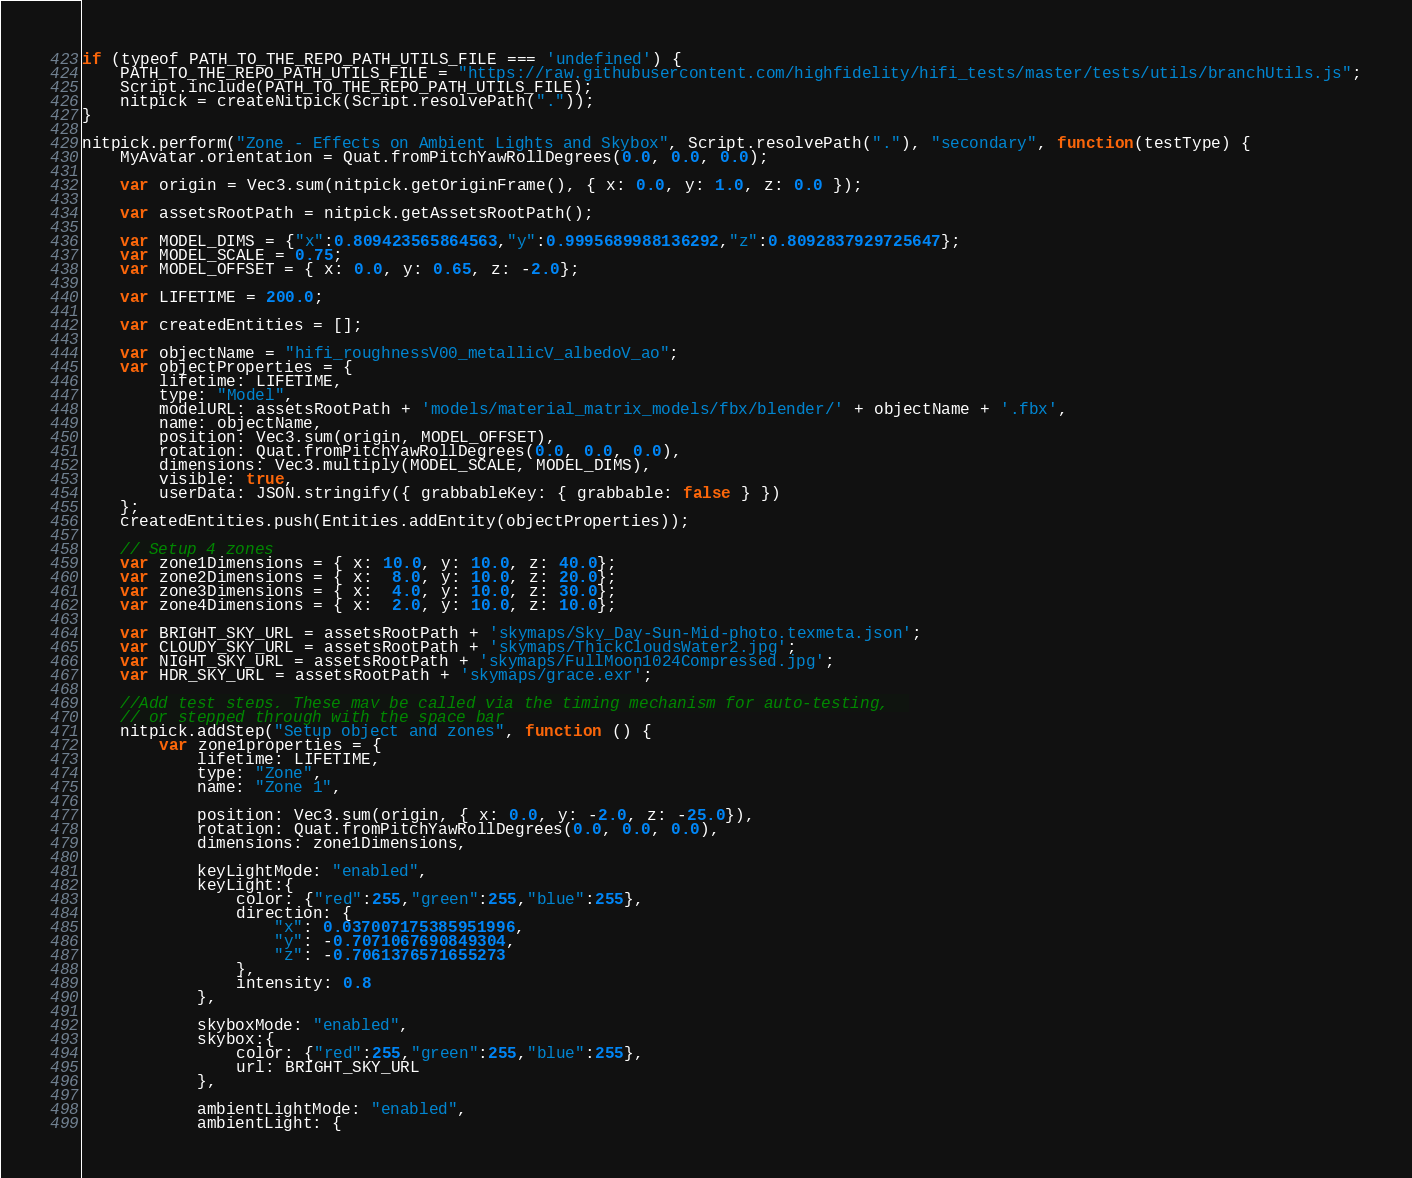Convert code to text. <code><loc_0><loc_0><loc_500><loc_500><_JavaScript_>if (typeof PATH_TO_THE_REPO_PATH_UTILS_FILE === 'undefined') {
    PATH_TO_THE_REPO_PATH_UTILS_FILE = "https://raw.githubusercontent.com/highfidelity/hifi_tests/master/tests/utils/branchUtils.js";
    Script.include(PATH_TO_THE_REPO_PATH_UTILS_FILE);
    nitpick = createNitpick(Script.resolvePath("."));
}

nitpick.perform("Zone - Effects on Ambient Lights and Skybox", Script.resolvePath("."), "secondary", function(testType) {
    MyAvatar.orientation = Quat.fromPitchYawRollDegrees(0.0, 0.0, 0.0);

    var origin = Vec3.sum(nitpick.getOriginFrame(), { x: 0.0, y: 1.0, z: 0.0 });

    var assetsRootPath = nitpick.getAssetsRootPath();

    var MODEL_DIMS = {"x":0.809423565864563,"y":0.9995689988136292,"z":0.8092837929725647};
    var MODEL_SCALE = 0.75;
    var MODEL_OFFSET = { x: 0.0, y: 0.65, z: -2.0};

    var LIFETIME = 200.0;

    var createdEntities = [];

    var objectName = "hifi_roughnessV00_metallicV_albedoV_ao";
    var objectProperties = {
        lifetime: LIFETIME,
        type: "Model",
        modelURL: assetsRootPath + 'models/material_matrix_models/fbx/blender/' + objectName + '.fbx',
        name: objectName,
        position: Vec3.sum(origin, MODEL_OFFSET),
        rotation: Quat.fromPitchYawRollDegrees(0.0, 0.0, 0.0),
        dimensions: Vec3.multiply(MODEL_SCALE, MODEL_DIMS),
        visible: true,
        userData: JSON.stringify({ grabbableKey: { grabbable: false } })
    };
    createdEntities.push(Entities.addEntity(objectProperties));

    // Setup 4 zones
    var zone1Dimensions = { x: 10.0, y: 10.0, z: 40.0};
    var zone2Dimensions = { x:  8.0, y: 10.0, z: 20.0};
    var zone3Dimensions = { x:  4.0, y: 10.0, z: 30.0};
    var zone4Dimensions = { x:  2.0, y: 10.0, z: 10.0};

    var BRIGHT_SKY_URL = assetsRootPath + 'skymaps/Sky_Day-Sun-Mid-photo.texmeta.json';
    var CLOUDY_SKY_URL = assetsRootPath + 'skymaps/ThickCloudsWater2.jpg';
    var NIGHT_SKY_URL = assetsRootPath + 'skymaps/FullMoon1024Compressed.jpg';
    var HDR_SKY_URL = assetsRootPath + 'skymaps/grace.exr';

    //Add test steps, These may be called via the timing mechanism for auto-testing,  
    // or stepped through with the space bar
    nitpick.addStep("Setup object and zones", function () {
        var zone1properties = {
            lifetime: LIFETIME,
            type: "Zone",
            name: "Zone 1",

            position: Vec3.sum(origin, { x: 0.0, y: -2.0, z: -25.0}),
            rotation: Quat.fromPitchYawRollDegrees(0.0, 0.0, 0.0),
            dimensions: zone1Dimensions,

            keyLightMode: "enabled",
            keyLight:{
                color: {"red":255,"green":255,"blue":255},
                direction: {
                    "x": 0.037007175385951996,
                    "y": -0.7071067690849304,
                    "z": -0.7061376571655273
                },
                intensity: 0.8
            },

            skyboxMode: "enabled",
            skybox:{
                color: {"red":255,"green":255,"blue":255},
                url: BRIGHT_SKY_URL
            },
            
            ambientLightMode: "enabled",
            ambientLight: {</code> 